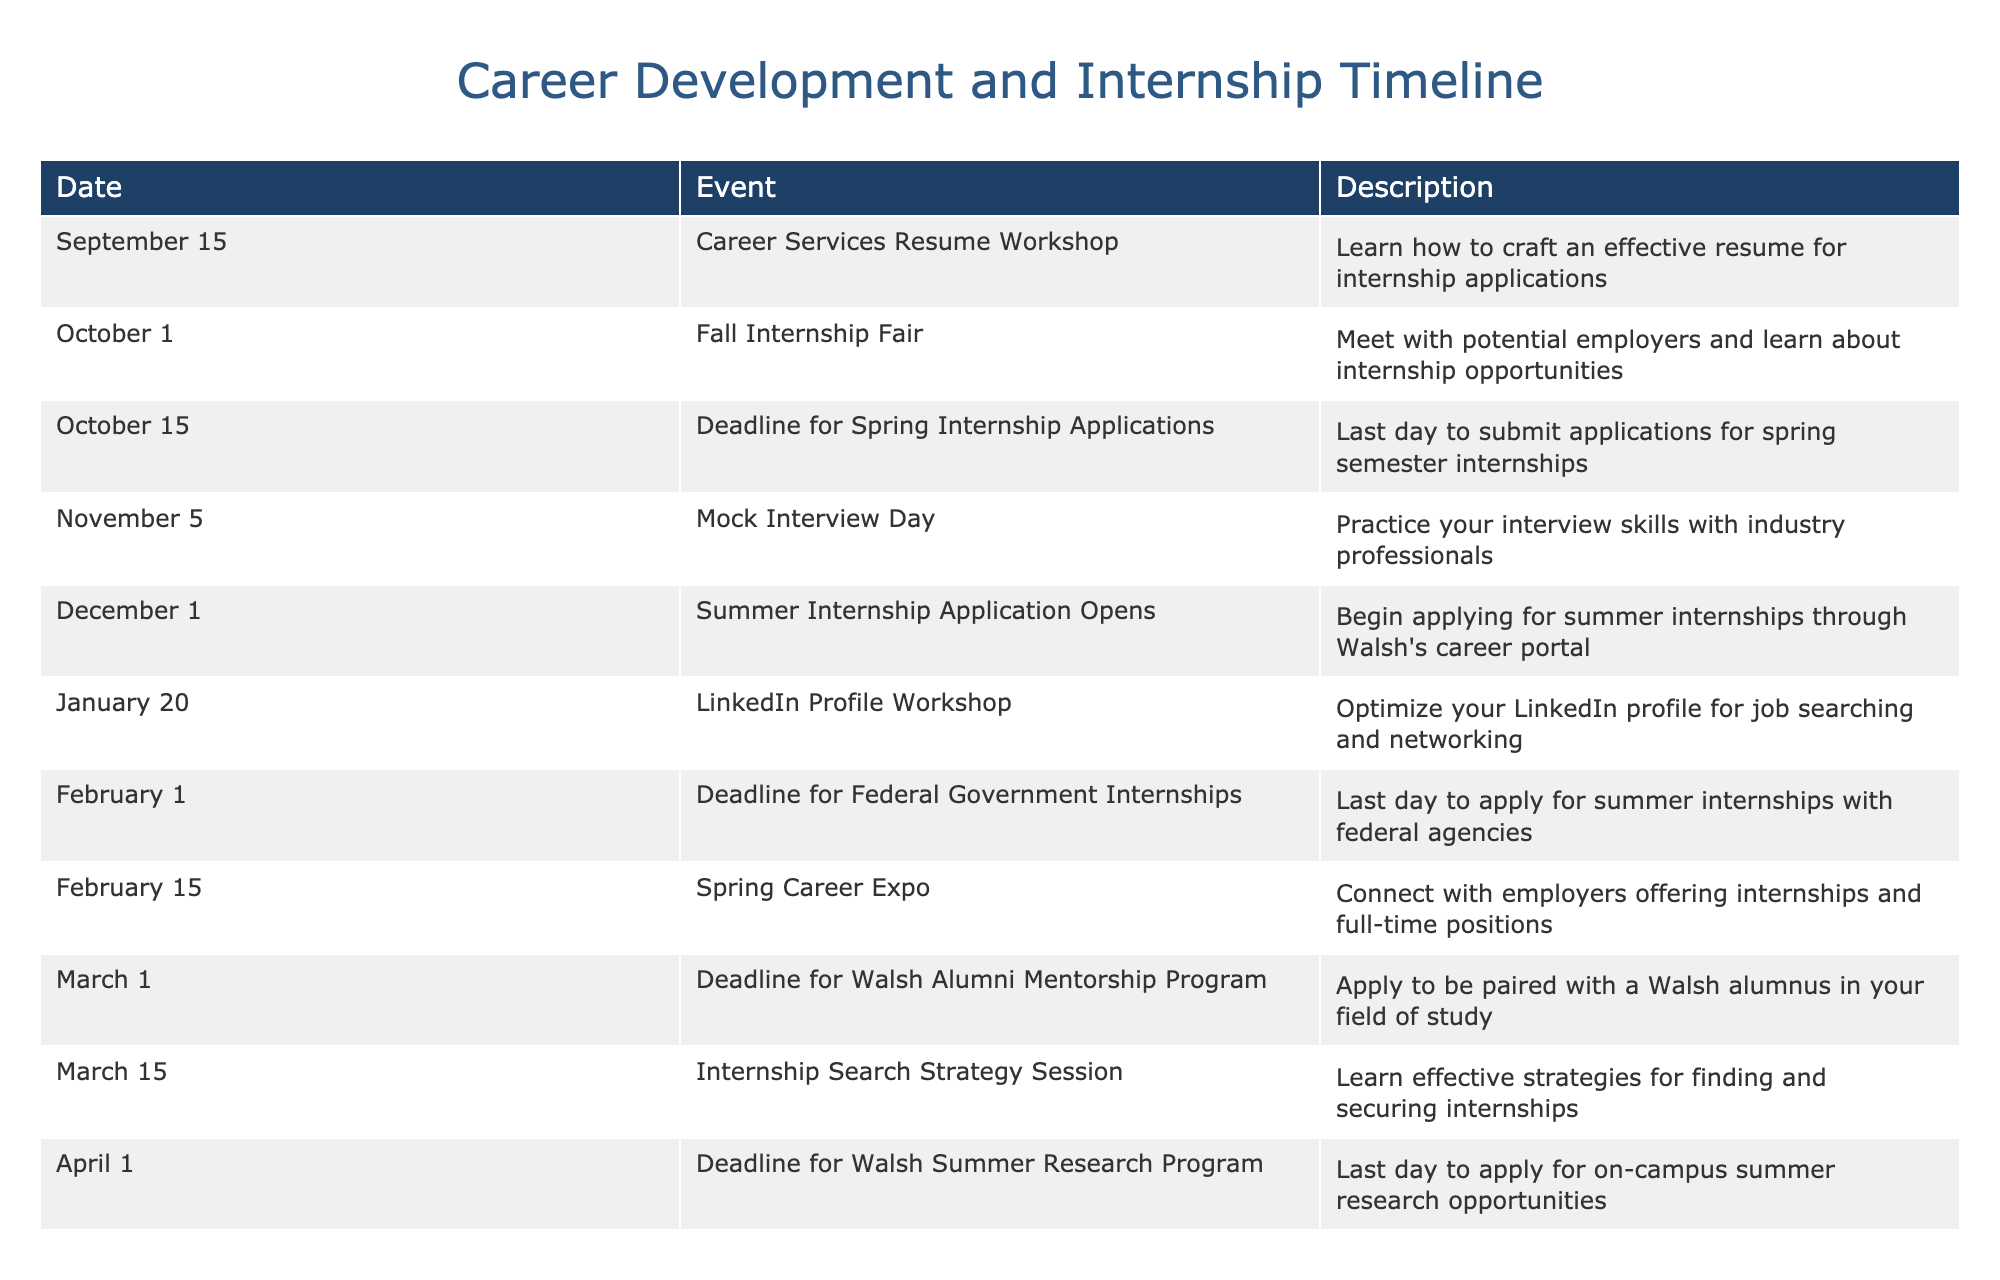What is the date of the Fall Internship Fair? The table lists various events along with their specific dates. To find the date for the Fall Internship Fair, I can look for the row where this event is mentioned, which shows that it is on October 1.
Answer: October 1 What event comes before the deadline for Spring Internship Applications? By examining the table, I can see that the "Fall Internship Fair" is the event that occurs right before the "Deadline for Spring Internship Applications," which is on October 15. The Fair is listed on October 1.
Answer: Fall Internship Fair How many events are scheduled in December? I need to count the rows in the table that correspond to December events. The only event listed in December is "Summer Internship Application Opens" on December 1. Therefore, there is just one event in December.
Answer: 1 What is the last day to apply for summer internships with federal agencies? From the table, I can see that the last date specified for applying for summer internships with federal agencies is February 1.
Answer: February 1 Are there any events scheduled after April 1? To answer this question, I look at the table and see which events are scheduled after April 1. There are two events: "Etiquette Dinner and Networking Event" on April 15 and "Deadline for Fall Internship Applications" on May 1, followed by "Summer Internship Orientation" on May 15.
Answer: Yes What is the total number of deadlines for internship applications listed? By examining the table, I count the deadlines for internship applications: October 15 for Spring Internships, February 1 for Federal Government Internships, May 1 for Fall Internships, and April 1 for Walsh Summer Research Program. This gives a total of four deadlines for applications.
Answer: 4 What is the median date of all the events? To find the median date, I need to first list out all the dates: September 15, October 1, October 15, November 5, December 1, January 20, February 1, February 15, March 1, March 15, April 1, April 15, May 1, and May 15. Arranging them in order, there are a total of 14 dates, so the median will be the average of the 7th and 8th dates (February 1 and February 15), which is February 8.
Answer: February 8 When is the last event listed in the table? I look at the table for the last event, which is listed last in the sequence of dates and events. The last event is "Summer Internship Orientation" on May 15.
Answer: May 15 